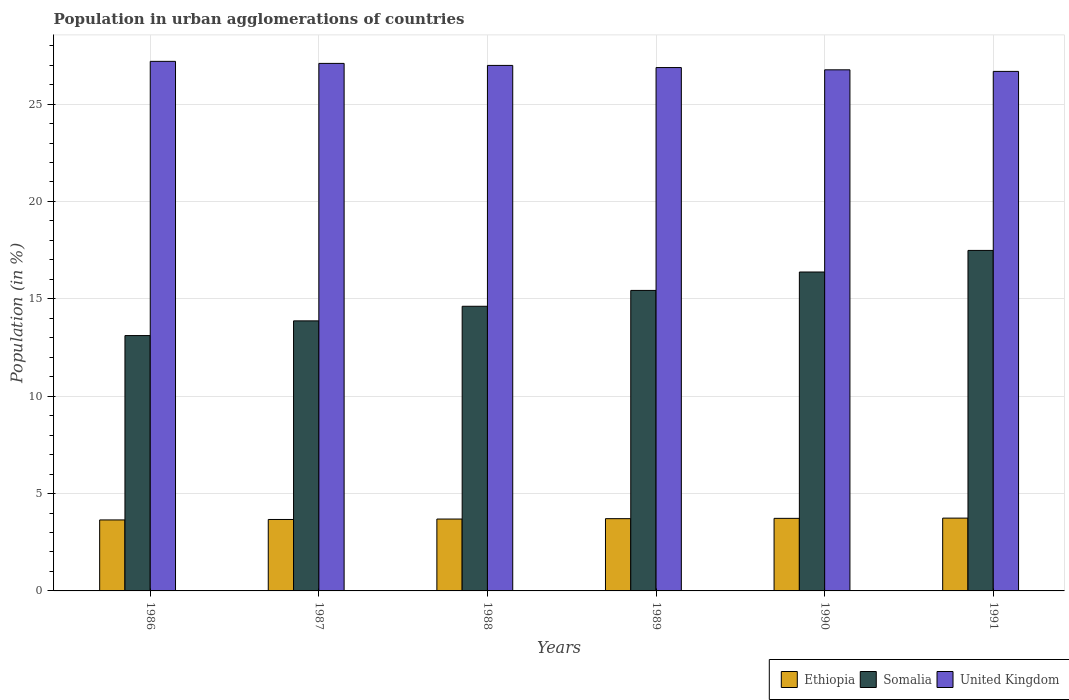How many different coloured bars are there?
Ensure brevity in your answer.  3. Are the number of bars on each tick of the X-axis equal?
Ensure brevity in your answer.  Yes. How many bars are there on the 6th tick from the right?
Keep it short and to the point. 3. What is the percentage of population in urban agglomerations in United Kingdom in 1990?
Ensure brevity in your answer.  26.76. Across all years, what is the maximum percentage of population in urban agglomerations in United Kingdom?
Keep it short and to the point. 27.19. Across all years, what is the minimum percentage of population in urban agglomerations in Somalia?
Give a very brief answer. 13.11. What is the total percentage of population in urban agglomerations in Somalia in the graph?
Ensure brevity in your answer.  90.89. What is the difference between the percentage of population in urban agglomerations in United Kingdom in 1986 and that in 1988?
Provide a succinct answer. 0.21. What is the difference between the percentage of population in urban agglomerations in United Kingdom in 1991 and the percentage of population in urban agglomerations in Somalia in 1990?
Offer a very short reply. 10.3. What is the average percentage of population in urban agglomerations in Somalia per year?
Provide a short and direct response. 15.15. In the year 1990, what is the difference between the percentage of population in urban agglomerations in Ethiopia and percentage of population in urban agglomerations in Somalia?
Provide a short and direct response. -12.65. In how many years, is the percentage of population in urban agglomerations in United Kingdom greater than 26 %?
Ensure brevity in your answer.  6. What is the ratio of the percentage of population in urban agglomerations in Somalia in 1987 to that in 1991?
Make the answer very short. 0.79. What is the difference between the highest and the second highest percentage of population in urban agglomerations in Somalia?
Ensure brevity in your answer.  1.11. What is the difference between the highest and the lowest percentage of population in urban agglomerations in Ethiopia?
Keep it short and to the point. 0.09. What does the 3rd bar from the right in 1991 represents?
Ensure brevity in your answer.  Ethiopia. How many years are there in the graph?
Keep it short and to the point. 6. Are the values on the major ticks of Y-axis written in scientific E-notation?
Your answer should be compact. No. Does the graph contain any zero values?
Give a very brief answer. No. Where does the legend appear in the graph?
Give a very brief answer. Bottom right. How many legend labels are there?
Offer a very short reply. 3. What is the title of the graph?
Ensure brevity in your answer.  Population in urban agglomerations of countries. What is the label or title of the X-axis?
Your answer should be compact. Years. What is the label or title of the Y-axis?
Your answer should be very brief. Population (in %). What is the Population (in %) of Ethiopia in 1986?
Provide a succinct answer. 3.65. What is the Population (in %) of Somalia in 1986?
Ensure brevity in your answer.  13.11. What is the Population (in %) of United Kingdom in 1986?
Provide a succinct answer. 27.19. What is the Population (in %) of Ethiopia in 1987?
Ensure brevity in your answer.  3.67. What is the Population (in %) in Somalia in 1987?
Offer a terse response. 13.87. What is the Population (in %) in United Kingdom in 1987?
Your answer should be compact. 27.09. What is the Population (in %) of Ethiopia in 1988?
Ensure brevity in your answer.  3.69. What is the Population (in %) in Somalia in 1988?
Ensure brevity in your answer.  14.62. What is the Population (in %) of United Kingdom in 1988?
Offer a very short reply. 26.98. What is the Population (in %) in Ethiopia in 1989?
Offer a very short reply. 3.71. What is the Population (in %) of Somalia in 1989?
Offer a very short reply. 15.43. What is the Population (in %) in United Kingdom in 1989?
Keep it short and to the point. 26.88. What is the Population (in %) of Ethiopia in 1990?
Offer a very short reply. 3.73. What is the Population (in %) in Somalia in 1990?
Your answer should be very brief. 16.38. What is the Population (in %) of United Kingdom in 1990?
Provide a short and direct response. 26.76. What is the Population (in %) in Ethiopia in 1991?
Offer a very short reply. 3.74. What is the Population (in %) in Somalia in 1991?
Keep it short and to the point. 17.49. What is the Population (in %) in United Kingdom in 1991?
Keep it short and to the point. 26.68. Across all years, what is the maximum Population (in %) in Ethiopia?
Provide a succinct answer. 3.74. Across all years, what is the maximum Population (in %) in Somalia?
Provide a short and direct response. 17.49. Across all years, what is the maximum Population (in %) in United Kingdom?
Offer a very short reply. 27.19. Across all years, what is the minimum Population (in %) of Ethiopia?
Make the answer very short. 3.65. Across all years, what is the minimum Population (in %) of Somalia?
Your answer should be compact. 13.11. Across all years, what is the minimum Population (in %) of United Kingdom?
Make the answer very short. 26.68. What is the total Population (in %) of Ethiopia in the graph?
Your answer should be very brief. 22.18. What is the total Population (in %) in Somalia in the graph?
Your answer should be compact. 90.89. What is the total Population (in %) of United Kingdom in the graph?
Keep it short and to the point. 161.58. What is the difference between the Population (in %) in Ethiopia in 1986 and that in 1987?
Your response must be concise. -0.02. What is the difference between the Population (in %) of Somalia in 1986 and that in 1987?
Ensure brevity in your answer.  -0.76. What is the difference between the Population (in %) of United Kingdom in 1986 and that in 1987?
Your response must be concise. 0.11. What is the difference between the Population (in %) of Ethiopia in 1986 and that in 1988?
Your answer should be compact. -0.05. What is the difference between the Population (in %) of Somalia in 1986 and that in 1988?
Offer a very short reply. -1.5. What is the difference between the Population (in %) in United Kingdom in 1986 and that in 1988?
Your answer should be compact. 0.21. What is the difference between the Population (in %) of Ethiopia in 1986 and that in 1989?
Provide a short and direct response. -0.07. What is the difference between the Population (in %) of Somalia in 1986 and that in 1989?
Your answer should be compact. -2.32. What is the difference between the Population (in %) in United Kingdom in 1986 and that in 1989?
Ensure brevity in your answer.  0.32. What is the difference between the Population (in %) of Ethiopia in 1986 and that in 1990?
Keep it short and to the point. -0.08. What is the difference between the Population (in %) in Somalia in 1986 and that in 1990?
Give a very brief answer. -3.26. What is the difference between the Population (in %) of United Kingdom in 1986 and that in 1990?
Provide a short and direct response. 0.43. What is the difference between the Population (in %) in Ethiopia in 1986 and that in 1991?
Your response must be concise. -0.09. What is the difference between the Population (in %) in Somalia in 1986 and that in 1991?
Provide a short and direct response. -4.37. What is the difference between the Population (in %) in United Kingdom in 1986 and that in 1991?
Your answer should be compact. 0.52. What is the difference between the Population (in %) in Ethiopia in 1987 and that in 1988?
Give a very brief answer. -0.02. What is the difference between the Population (in %) in Somalia in 1987 and that in 1988?
Offer a very short reply. -0.75. What is the difference between the Population (in %) in United Kingdom in 1987 and that in 1988?
Your answer should be compact. 0.1. What is the difference between the Population (in %) in Ethiopia in 1987 and that in 1989?
Offer a very short reply. -0.04. What is the difference between the Population (in %) of Somalia in 1987 and that in 1989?
Your answer should be compact. -1.56. What is the difference between the Population (in %) in United Kingdom in 1987 and that in 1989?
Your answer should be very brief. 0.21. What is the difference between the Population (in %) in Ethiopia in 1987 and that in 1990?
Offer a terse response. -0.06. What is the difference between the Population (in %) in Somalia in 1987 and that in 1990?
Your answer should be very brief. -2.51. What is the difference between the Population (in %) of United Kingdom in 1987 and that in 1990?
Your response must be concise. 0.33. What is the difference between the Population (in %) in Ethiopia in 1987 and that in 1991?
Offer a terse response. -0.07. What is the difference between the Population (in %) in Somalia in 1987 and that in 1991?
Ensure brevity in your answer.  -3.62. What is the difference between the Population (in %) in United Kingdom in 1987 and that in 1991?
Provide a short and direct response. 0.41. What is the difference between the Population (in %) in Ethiopia in 1988 and that in 1989?
Provide a short and direct response. -0.02. What is the difference between the Population (in %) in Somalia in 1988 and that in 1989?
Keep it short and to the point. -0.81. What is the difference between the Population (in %) in United Kingdom in 1988 and that in 1989?
Make the answer very short. 0.11. What is the difference between the Population (in %) of Ethiopia in 1988 and that in 1990?
Your answer should be very brief. -0.04. What is the difference between the Population (in %) of Somalia in 1988 and that in 1990?
Your response must be concise. -1.76. What is the difference between the Population (in %) of United Kingdom in 1988 and that in 1990?
Provide a short and direct response. 0.23. What is the difference between the Population (in %) in Ethiopia in 1988 and that in 1991?
Your response must be concise. -0.05. What is the difference between the Population (in %) of Somalia in 1988 and that in 1991?
Your response must be concise. -2.87. What is the difference between the Population (in %) of United Kingdom in 1988 and that in 1991?
Provide a short and direct response. 0.31. What is the difference between the Population (in %) in Ethiopia in 1989 and that in 1990?
Your response must be concise. -0.02. What is the difference between the Population (in %) of Somalia in 1989 and that in 1990?
Offer a terse response. -0.95. What is the difference between the Population (in %) of United Kingdom in 1989 and that in 1990?
Offer a very short reply. 0.12. What is the difference between the Population (in %) of Ethiopia in 1989 and that in 1991?
Provide a short and direct response. -0.03. What is the difference between the Population (in %) in Somalia in 1989 and that in 1991?
Provide a short and direct response. -2.05. What is the difference between the Population (in %) in United Kingdom in 1989 and that in 1991?
Provide a succinct answer. 0.2. What is the difference between the Population (in %) of Ethiopia in 1990 and that in 1991?
Your response must be concise. -0.01. What is the difference between the Population (in %) of Somalia in 1990 and that in 1991?
Provide a short and direct response. -1.11. What is the difference between the Population (in %) in United Kingdom in 1990 and that in 1991?
Provide a short and direct response. 0.08. What is the difference between the Population (in %) of Ethiopia in 1986 and the Population (in %) of Somalia in 1987?
Your response must be concise. -10.22. What is the difference between the Population (in %) of Ethiopia in 1986 and the Population (in %) of United Kingdom in 1987?
Your response must be concise. -23.44. What is the difference between the Population (in %) in Somalia in 1986 and the Population (in %) in United Kingdom in 1987?
Offer a terse response. -13.98. What is the difference between the Population (in %) of Ethiopia in 1986 and the Population (in %) of Somalia in 1988?
Make the answer very short. -10.97. What is the difference between the Population (in %) in Ethiopia in 1986 and the Population (in %) in United Kingdom in 1988?
Your answer should be compact. -23.34. What is the difference between the Population (in %) in Somalia in 1986 and the Population (in %) in United Kingdom in 1988?
Offer a very short reply. -13.87. What is the difference between the Population (in %) in Ethiopia in 1986 and the Population (in %) in Somalia in 1989?
Make the answer very short. -11.79. What is the difference between the Population (in %) in Ethiopia in 1986 and the Population (in %) in United Kingdom in 1989?
Ensure brevity in your answer.  -23.23. What is the difference between the Population (in %) of Somalia in 1986 and the Population (in %) of United Kingdom in 1989?
Offer a very short reply. -13.76. What is the difference between the Population (in %) of Ethiopia in 1986 and the Population (in %) of Somalia in 1990?
Keep it short and to the point. -12.73. What is the difference between the Population (in %) of Ethiopia in 1986 and the Population (in %) of United Kingdom in 1990?
Your answer should be compact. -23.11. What is the difference between the Population (in %) of Somalia in 1986 and the Population (in %) of United Kingdom in 1990?
Offer a terse response. -13.65. What is the difference between the Population (in %) in Ethiopia in 1986 and the Population (in %) in Somalia in 1991?
Offer a very short reply. -13.84. What is the difference between the Population (in %) of Ethiopia in 1986 and the Population (in %) of United Kingdom in 1991?
Make the answer very short. -23.03. What is the difference between the Population (in %) in Somalia in 1986 and the Population (in %) in United Kingdom in 1991?
Your answer should be compact. -13.57. What is the difference between the Population (in %) in Ethiopia in 1987 and the Population (in %) in Somalia in 1988?
Make the answer very short. -10.95. What is the difference between the Population (in %) in Ethiopia in 1987 and the Population (in %) in United Kingdom in 1988?
Make the answer very short. -23.32. What is the difference between the Population (in %) of Somalia in 1987 and the Population (in %) of United Kingdom in 1988?
Your answer should be compact. -13.12. What is the difference between the Population (in %) in Ethiopia in 1987 and the Population (in %) in Somalia in 1989?
Offer a terse response. -11.76. What is the difference between the Population (in %) of Ethiopia in 1987 and the Population (in %) of United Kingdom in 1989?
Provide a short and direct response. -23.21. What is the difference between the Population (in %) of Somalia in 1987 and the Population (in %) of United Kingdom in 1989?
Give a very brief answer. -13.01. What is the difference between the Population (in %) of Ethiopia in 1987 and the Population (in %) of Somalia in 1990?
Provide a succinct answer. -12.71. What is the difference between the Population (in %) of Ethiopia in 1987 and the Population (in %) of United Kingdom in 1990?
Your answer should be compact. -23.09. What is the difference between the Population (in %) in Somalia in 1987 and the Population (in %) in United Kingdom in 1990?
Provide a succinct answer. -12.89. What is the difference between the Population (in %) in Ethiopia in 1987 and the Population (in %) in Somalia in 1991?
Offer a very short reply. -13.82. What is the difference between the Population (in %) in Ethiopia in 1987 and the Population (in %) in United Kingdom in 1991?
Provide a short and direct response. -23.01. What is the difference between the Population (in %) of Somalia in 1987 and the Population (in %) of United Kingdom in 1991?
Offer a terse response. -12.81. What is the difference between the Population (in %) in Ethiopia in 1988 and the Population (in %) in Somalia in 1989?
Your answer should be very brief. -11.74. What is the difference between the Population (in %) in Ethiopia in 1988 and the Population (in %) in United Kingdom in 1989?
Your response must be concise. -23.18. What is the difference between the Population (in %) of Somalia in 1988 and the Population (in %) of United Kingdom in 1989?
Your answer should be very brief. -12.26. What is the difference between the Population (in %) of Ethiopia in 1988 and the Population (in %) of Somalia in 1990?
Your answer should be very brief. -12.68. What is the difference between the Population (in %) of Ethiopia in 1988 and the Population (in %) of United Kingdom in 1990?
Ensure brevity in your answer.  -23.07. What is the difference between the Population (in %) of Somalia in 1988 and the Population (in %) of United Kingdom in 1990?
Offer a terse response. -12.14. What is the difference between the Population (in %) in Ethiopia in 1988 and the Population (in %) in Somalia in 1991?
Ensure brevity in your answer.  -13.79. What is the difference between the Population (in %) of Ethiopia in 1988 and the Population (in %) of United Kingdom in 1991?
Give a very brief answer. -22.99. What is the difference between the Population (in %) in Somalia in 1988 and the Population (in %) in United Kingdom in 1991?
Your response must be concise. -12.06. What is the difference between the Population (in %) in Ethiopia in 1989 and the Population (in %) in Somalia in 1990?
Offer a terse response. -12.67. What is the difference between the Population (in %) in Ethiopia in 1989 and the Population (in %) in United Kingdom in 1990?
Your answer should be very brief. -23.05. What is the difference between the Population (in %) of Somalia in 1989 and the Population (in %) of United Kingdom in 1990?
Provide a short and direct response. -11.33. What is the difference between the Population (in %) in Ethiopia in 1989 and the Population (in %) in Somalia in 1991?
Provide a succinct answer. -13.77. What is the difference between the Population (in %) of Ethiopia in 1989 and the Population (in %) of United Kingdom in 1991?
Your response must be concise. -22.97. What is the difference between the Population (in %) in Somalia in 1989 and the Population (in %) in United Kingdom in 1991?
Offer a very short reply. -11.25. What is the difference between the Population (in %) in Ethiopia in 1990 and the Population (in %) in Somalia in 1991?
Make the answer very short. -13.76. What is the difference between the Population (in %) in Ethiopia in 1990 and the Population (in %) in United Kingdom in 1991?
Provide a succinct answer. -22.95. What is the difference between the Population (in %) in Somalia in 1990 and the Population (in %) in United Kingdom in 1991?
Offer a terse response. -10.3. What is the average Population (in %) in Ethiopia per year?
Provide a succinct answer. 3.7. What is the average Population (in %) of Somalia per year?
Keep it short and to the point. 15.15. What is the average Population (in %) of United Kingdom per year?
Your response must be concise. 26.93. In the year 1986, what is the difference between the Population (in %) of Ethiopia and Population (in %) of Somalia?
Ensure brevity in your answer.  -9.47. In the year 1986, what is the difference between the Population (in %) of Ethiopia and Population (in %) of United Kingdom?
Keep it short and to the point. -23.55. In the year 1986, what is the difference between the Population (in %) of Somalia and Population (in %) of United Kingdom?
Ensure brevity in your answer.  -14.08. In the year 1987, what is the difference between the Population (in %) in Ethiopia and Population (in %) in Somalia?
Offer a very short reply. -10.2. In the year 1987, what is the difference between the Population (in %) in Ethiopia and Population (in %) in United Kingdom?
Provide a succinct answer. -23.42. In the year 1987, what is the difference between the Population (in %) of Somalia and Population (in %) of United Kingdom?
Give a very brief answer. -13.22. In the year 1988, what is the difference between the Population (in %) in Ethiopia and Population (in %) in Somalia?
Provide a short and direct response. -10.93. In the year 1988, what is the difference between the Population (in %) in Ethiopia and Population (in %) in United Kingdom?
Your answer should be compact. -23.29. In the year 1988, what is the difference between the Population (in %) of Somalia and Population (in %) of United Kingdom?
Keep it short and to the point. -12.37. In the year 1989, what is the difference between the Population (in %) of Ethiopia and Population (in %) of Somalia?
Provide a succinct answer. -11.72. In the year 1989, what is the difference between the Population (in %) of Ethiopia and Population (in %) of United Kingdom?
Keep it short and to the point. -23.16. In the year 1989, what is the difference between the Population (in %) in Somalia and Population (in %) in United Kingdom?
Offer a very short reply. -11.44. In the year 1990, what is the difference between the Population (in %) of Ethiopia and Population (in %) of Somalia?
Keep it short and to the point. -12.65. In the year 1990, what is the difference between the Population (in %) of Ethiopia and Population (in %) of United Kingdom?
Give a very brief answer. -23.03. In the year 1990, what is the difference between the Population (in %) in Somalia and Population (in %) in United Kingdom?
Make the answer very short. -10.38. In the year 1991, what is the difference between the Population (in %) in Ethiopia and Population (in %) in Somalia?
Keep it short and to the point. -13.75. In the year 1991, what is the difference between the Population (in %) in Ethiopia and Population (in %) in United Kingdom?
Your answer should be compact. -22.94. In the year 1991, what is the difference between the Population (in %) in Somalia and Population (in %) in United Kingdom?
Ensure brevity in your answer.  -9.19. What is the ratio of the Population (in %) in Somalia in 1986 to that in 1987?
Ensure brevity in your answer.  0.95. What is the ratio of the Population (in %) of United Kingdom in 1986 to that in 1987?
Your response must be concise. 1. What is the ratio of the Population (in %) of Ethiopia in 1986 to that in 1988?
Keep it short and to the point. 0.99. What is the ratio of the Population (in %) of Somalia in 1986 to that in 1988?
Provide a short and direct response. 0.9. What is the ratio of the Population (in %) in United Kingdom in 1986 to that in 1988?
Make the answer very short. 1.01. What is the ratio of the Population (in %) of Ethiopia in 1986 to that in 1989?
Your answer should be very brief. 0.98. What is the ratio of the Population (in %) in Somalia in 1986 to that in 1989?
Offer a very short reply. 0.85. What is the ratio of the Population (in %) of United Kingdom in 1986 to that in 1989?
Offer a terse response. 1.01. What is the ratio of the Population (in %) of Ethiopia in 1986 to that in 1990?
Your response must be concise. 0.98. What is the ratio of the Population (in %) in Somalia in 1986 to that in 1990?
Offer a very short reply. 0.8. What is the ratio of the Population (in %) in United Kingdom in 1986 to that in 1990?
Make the answer very short. 1.02. What is the ratio of the Population (in %) of Ethiopia in 1986 to that in 1991?
Keep it short and to the point. 0.97. What is the ratio of the Population (in %) of Somalia in 1986 to that in 1991?
Provide a succinct answer. 0.75. What is the ratio of the Population (in %) of United Kingdom in 1986 to that in 1991?
Provide a short and direct response. 1.02. What is the ratio of the Population (in %) of Somalia in 1987 to that in 1988?
Ensure brevity in your answer.  0.95. What is the ratio of the Population (in %) of United Kingdom in 1987 to that in 1988?
Keep it short and to the point. 1. What is the ratio of the Population (in %) of Somalia in 1987 to that in 1989?
Provide a short and direct response. 0.9. What is the ratio of the Population (in %) of United Kingdom in 1987 to that in 1989?
Provide a short and direct response. 1.01. What is the ratio of the Population (in %) of Ethiopia in 1987 to that in 1990?
Provide a short and direct response. 0.98. What is the ratio of the Population (in %) in Somalia in 1987 to that in 1990?
Your answer should be very brief. 0.85. What is the ratio of the Population (in %) of United Kingdom in 1987 to that in 1990?
Ensure brevity in your answer.  1.01. What is the ratio of the Population (in %) in Ethiopia in 1987 to that in 1991?
Offer a very short reply. 0.98. What is the ratio of the Population (in %) of Somalia in 1987 to that in 1991?
Keep it short and to the point. 0.79. What is the ratio of the Population (in %) in United Kingdom in 1987 to that in 1991?
Your response must be concise. 1.02. What is the ratio of the Population (in %) in Somalia in 1988 to that in 1989?
Provide a short and direct response. 0.95. What is the ratio of the Population (in %) of United Kingdom in 1988 to that in 1989?
Your answer should be compact. 1. What is the ratio of the Population (in %) in Ethiopia in 1988 to that in 1990?
Make the answer very short. 0.99. What is the ratio of the Population (in %) of Somalia in 1988 to that in 1990?
Your answer should be very brief. 0.89. What is the ratio of the Population (in %) in United Kingdom in 1988 to that in 1990?
Provide a short and direct response. 1.01. What is the ratio of the Population (in %) of Ethiopia in 1988 to that in 1991?
Keep it short and to the point. 0.99. What is the ratio of the Population (in %) of Somalia in 1988 to that in 1991?
Make the answer very short. 0.84. What is the ratio of the Population (in %) in United Kingdom in 1988 to that in 1991?
Keep it short and to the point. 1.01. What is the ratio of the Population (in %) of Somalia in 1989 to that in 1990?
Your response must be concise. 0.94. What is the ratio of the Population (in %) of Ethiopia in 1989 to that in 1991?
Your response must be concise. 0.99. What is the ratio of the Population (in %) in Somalia in 1989 to that in 1991?
Keep it short and to the point. 0.88. What is the ratio of the Population (in %) of United Kingdom in 1989 to that in 1991?
Provide a short and direct response. 1.01. What is the ratio of the Population (in %) in Somalia in 1990 to that in 1991?
Your answer should be very brief. 0.94. What is the ratio of the Population (in %) in United Kingdom in 1990 to that in 1991?
Your response must be concise. 1. What is the difference between the highest and the second highest Population (in %) of Ethiopia?
Offer a very short reply. 0.01. What is the difference between the highest and the second highest Population (in %) of Somalia?
Provide a succinct answer. 1.11. What is the difference between the highest and the second highest Population (in %) in United Kingdom?
Ensure brevity in your answer.  0.11. What is the difference between the highest and the lowest Population (in %) in Ethiopia?
Your response must be concise. 0.09. What is the difference between the highest and the lowest Population (in %) in Somalia?
Offer a very short reply. 4.37. What is the difference between the highest and the lowest Population (in %) in United Kingdom?
Keep it short and to the point. 0.52. 